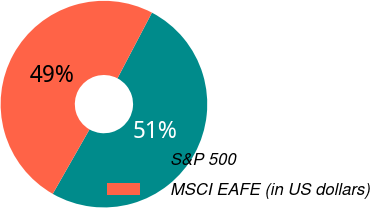<chart> <loc_0><loc_0><loc_500><loc_500><pie_chart><fcel>S&P 500<fcel>MSCI EAFE (in US dollars)<nl><fcel>50.56%<fcel>49.44%<nl></chart> 